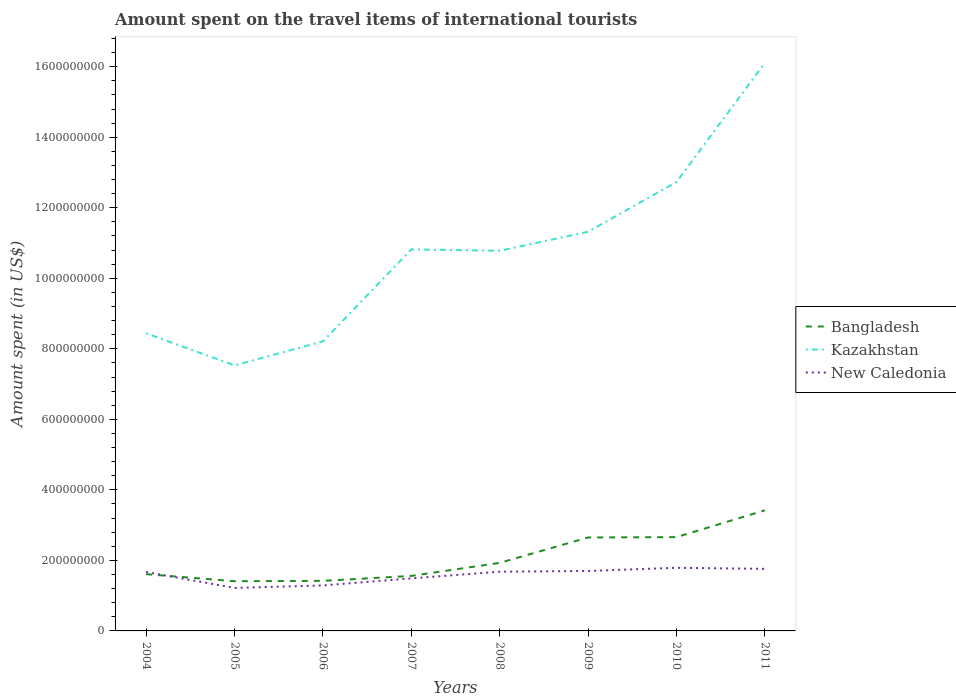How many different coloured lines are there?
Ensure brevity in your answer.  3. Across all years, what is the maximum amount spent on the travel items of international tourists in Kazakhstan?
Ensure brevity in your answer.  7.53e+08. In which year was the amount spent on the travel items of international tourists in Kazakhstan maximum?
Provide a short and direct response. 2005. What is the total amount spent on the travel items of international tourists in New Caledonia in the graph?
Ensure brevity in your answer.  -3.90e+07. What is the difference between the highest and the second highest amount spent on the travel items of international tourists in Bangladesh?
Provide a short and direct response. 2.01e+08. Is the amount spent on the travel items of international tourists in New Caledonia strictly greater than the amount spent on the travel items of international tourists in Bangladesh over the years?
Make the answer very short. No. How many years are there in the graph?
Ensure brevity in your answer.  8. Are the values on the major ticks of Y-axis written in scientific E-notation?
Provide a short and direct response. No. Does the graph contain any zero values?
Your answer should be very brief. No. Where does the legend appear in the graph?
Make the answer very short. Center right. How many legend labels are there?
Make the answer very short. 3. What is the title of the graph?
Offer a very short reply. Amount spent on the travel items of international tourists. Does "Palau" appear as one of the legend labels in the graph?
Provide a short and direct response. No. What is the label or title of the X-axis?
Offer a terse response. Years. What is the label or title of the Y-axis?
Provide a succinct answer. Amount spent (in US$). What is the Amount spent (in US$) of Bangladesh in 2004?
Provide a short and direct response. 1.61e+08. What is the Amount spent (in US$) of Kazakhstan in 2004?
Make the answer very short. 8.44e+08. What is the Amount spent (in US$) of New Caledonia in 2004?
Offer a very short reply. 1.67e+08. What is the Amount spent (in US$) in Bangladesh in 2005?
Your answer should be very brief. 1.41e+08. What is the Amount spent (in US$) of Kazakhstan in 2005?
Your answer should be compact. 7.53e+08. What is the Amount spent (in US$) of New Caledonia in 2005?
Your response must be concise. 1.22e+08. What is the Amount spent (in US$) of Bangladesh in 2006?
Offer a terse response. 1.42e+08. What is the Amount spent (in US$) in Kazakhstan in 2006?
Provide a succinct answer. 8.21e+08. What is the Amount spent (in US$) in New Caledonia in 2006?
Offer a terse response. 1.29e+08. What is the Amount spent (in US$) of Bangladesh in 2007?
Provide a succinct answer. 1.56e+08. What is the Amount spent (in US$) in Kazakhstan in 2007?
Offer a terse response. 1.08e+09. What is the Amount spent (in US$) in New Caledonia in 2007?
Make the answer very short. 1.49e+08. What is the Amount spent (in US$) of Bangladesh in 2008?
Your answer should be compact. 1.93e+08. What is the Amount spent (in US$) in Kazakhstan in 2008?
Your answer should be very brief. 1.08e+09. What is the Amount spent (in US$) in New Caledonia in 2008?
Make the answer very short. 1.68e+08. What is the Amount spent (in US$) of Bangladesh in 2009?
Your response must be concise. 2.65e+08. What is the Amount spent (in US$) in Kazakhstan in 2009?
Keep it short and to the point. 1.13e+09. What is the Amount spent (in US$) in New Caledonia in 2009?
Your answer should be compact. 1.70e+08. What is the Amount spent (in US$) in Bangladesh in 2010?
Provide a succinct answer. 2.66e+08. What is the Amount spent (in US$) in Kazakhstan in 2010?
Provide a succinct answer. 1.27e+09. What is the Amount spent (in US$) in New Caledonia in 2010?
Give a very brief answer. 1.79e+08. What is the Amount spent (in US$) in Bangladesh in 2011?
Your response must be concise. 3.42e+08. What is the Amount spent (in US$) of Kazakhstan in 2011?
Ensure brevity in your answer.  1.61e+09. What is the Amount spent (in US$) of New Caledonia in 2011?
Offer a very short reply. 1.76e+08. Across all years, what is the maximum Amount spent (in US$) of Bangladesh?
Your answer should be compact. 3.42e+08. Across all years, what is the maximum Amount spent (in US$) in Kazakhstan?
Offer a very short reply. 1.61e+09. Across all years, what is the maximum Amount spent (in US$) in New Caledonia?
Your answer should be compact. 1.79e+08. Across all years, what is the minimum Amount spent (in US$) of Bangladesh?
Your answer should be compact. 1.41e+08. Across all years, what is the minimum Amount spent (in US$) of Kazakhstan?
Give a very brief answer. 7.53e+08. Across all years, what is the minimum Amount spent (in US$) of New Caledonia?
Your answer should be compact. 1.22e+08. What is the total Amount spent (in US$) in Bangladesh in the graph?
Your answer should be very brief. 1.67e+09. What is the total Amount spent (in US$) in Kazakhstan in the graph?
Your response must be concise. 8.59e+09. What is the total Amount spent (in US$) of New Caledonia in the graph?
Offer a very short reply. 1.26e+09. What is the difference between the Amount spent (in US$) of Bangladesh in 2004 and that in 2005?
Ensure brevity in your answer.  2.00e+07. What is the difference between the Amount spent (in US$) in Kazakhstan in 2004 and that in 2005?
Give a very brief answer. 9.10e+07. What is the difference between the Amount spent (in US$) of New Caledonia in 2004 and that in 2005?
Your answer should be compact. 4.50e+07. What is the difference between the Amount spent (in US$) of Bangladesh in 2004 and that in 2006?
Offer a terse response. 1.90e+07. What is the difference between the Amount spent (in US$) in Kazakhstan in 2004 and that in 2006?
Make the answer very short. 2.30e+07. What is the difference between the Amount spent (in US$) of New Caledonia in 2004 and that in 2006?
Provide a short and direct response. 3.80e+07. What is the difference between the Amount spent (in US$) in Kazakhstan in 2004 and that in 2007?
Provide a succinct answer. -2.38e+08. What is the difference between the Amount spent (in US$) in New Caledonia in 2004 and that in 2007?
Provide a short and direct response. 1.80e+07. What is the difference between the Amount spent (in US$) in Bangladesh in 2004 and that in 2008?
Your answer should be compact. -3.20e+07. What is the difference between the Amount spent (in US$) of Kazakhstan in 2004 and that in 2008?
Make the answer very short. -2.34e+08. What is the difference between the Amount spent (in US$) of Bangladesh in 2004 and that in 2009?
Offer a very short reply. -1.04e+08. What is the difference between the Amount spent (in US$) of Kazakhstan in 2004 and that in 2009?
Your response must be concise. -2.88e+08. What is the difference between the Amount spent (in US$) in Bangladesh in 2004 and that in 2010?
Offer a terse response. -1.05e+08. What is the difference between the Amount spent (in US$) of Kazakhstan in 2004 and that in 2010?
Make the answer very short. -4.29e+08. What is the difference between the Amount spent (in US$) in New Caledonia in 2004 and that in 2010?
Ensure brevity in your answer.  -1.20e+07. What is the difference between the Amount spent (in US$) in Bangladesh in 2004 and that in 2011?
Keep it short and to the point. -1.81e+08. What is the difference between the Amount spent (in US$) in Kazakhstan in 2004 and that in 2011?
Offer a terse response. -7.67e+08. What is the difference between the Amount spent (in US$) of New Caledonia in 2004 and that in 2011?
Offer a terse response. -9.00e+06. What is the difference between the Amount spent (in US$) in Bangladesh in 2005 and that in 2006?
Keep it short and to the point. -1.00e+06. What is the difference between the Amount spent (in US$) in Kazakhstan in 2005 and that in 2006?
Your answer should be compact. -6.80e+07. What is the difference between the Amount spent (in US$) of New Caledonia in 2005 and that in 2006?
Your response must be concise. -7.00e+06. What is the difference between the Amount spent (in US$) in Bangladesh in 2005 and that in 2007?
Offer a terse response. -1.50e+07. What is the difference between the Amount spent (in US$) in Kazakhstan in 2005 and that in 2007?
Your answer should be compact. -3.29e+08. What is the difference between the Amount spent (in US$) of New Caledonia in 2005 and that in 2007?
Your response must be concise. -2.70e+07. What is the difference between the Amount spent (in US$) in Bangladesh in 2005 and that in 2008?
Keep it short and to the point. -5.20e+07. What is the difference between the Amount spent (in US$) of Kazakhstan in 2005 and that in 2008?
Provide a short and direct response. -3.25e+08. What is the difference between the Amount spent (in US$) of New Caledonia in 2005 and that in 2008?
Your response must be concise. -4.60e+07. What is the difference between the Amount spent (in US$) of Bangladesh in 2005 and that in 2009?
Offer a terse response. -1.24e+08. What is the difference between the Amount spent (in US$) of Kazakhstan in 2005 and that in 2009?
Offer a terse response. -3.79e+08. What is the difference between the Amount spent (in US$) of New Caledonia in 2005 and that in 2009?
Give a very brief answer. -4.80e+07. What is the difference between the Amount spent (in US$) of Bangladesh in 2005 and that in 2010?
Provide a short and direct response. -1.25e+08. What is the difference between the Amount spent (in US$) in Kazakhstan in 2005 and that in 2010?
Your answer should be very brief. -5.20e+08. What is the difference between the Amount spent (in US$) of New Caledonia in 2005 and that in 2010?
Make the answer very short. -5.70e+07. What is the difference between the Amount spent (in US$) of Bangladesh in 2005 and that in 2011?
Provide a short and direct response. -2.01e+08. What is the difference between the Amount spent (in US$) in Kazakhstan in 2005 and that in 2011?
Offer a very short reply. -8.58e+08. What is the difference between the Amount spent (in US$) in New Caledonia in 2005 and that in 2011?
Keep it short and to the point. -5.40e+07. What is the difference between the Amount spent (in US$) of Bangladesh in 2006 and that in 2007?
Offer a very short reply. -1.40e+07. What is the difference between the Amount spent (in US$) in Kazakhstan in 2006 and that in 2007?
Offer a terse response. -2.61e+08. What is the difference between the Amount spent (in US$) of New Caledonia in 2006 and that in 2007?
Your response must be concise. -2.00e+07. What is the difference between the Amount spent (in US$) of Bangladesh in 2006 and that in 2008?
Offer a very short reply. -5.10e+07. What is the difference between the Amount spent (in US$) of Kazakhstan in 2006 and that in 2008?
Your response must be concise. -2.57e+08. What is the difference between the Amount spent (in US$) in New Caledonia in 2006 and that in 2008?
Your answer should be compact. -3.90e+07. What is the difference between the Amount spent (in US$) in Bangladesh in 2006 and that in 2009?
Keep it short and to the point. -1.23e+08. What is the difference between the Amount spent (in US$) of Kazakhstan in 2006 and that in 2009?
Provide a succinct answer. -3.11e+08. What is the difference between the Amount spent (in US$) in New Caledonia in 2006 and that in 2009?
Your answer should be compact. -4.10e+07. What is the difference between the Amount spent (in US$) in Bangladesh in 2006 and that in 2010?
Provide a short and direct response. -1.24e+08. What is the difference between the Amount spent (in US$) in Kazakhstan in 2006 and that in 2010?
Keep it short and to the point. -4.52e+08. What is the difference between the Amount spent (in US$) in New Caledonia in 2006 and that in 2010?
Offer a terse response. -5.00e+07. What is the difference between the Amount spent (in US$) in Bangladesh in 2006 and that in 2011?
Make the answer very short. -2.00e+08. What is the difference between the Amount spent (in US$) of Kazakhstan in 2006 and that in 2011?
Offer a very short reply. -7.90e+08. What is the difference between the Amount spent (in US$) in New Caledonia in 2006 and that in 2011?
Make the answer very short. -4.70e+07. What is the difference between the Amount spent (in US$) in Bangladesh in 2007 and that in 2008?
Give a very brief answer. -3.70e+07. What is the difference between the Amount spent (in US$) in Kazakhstan in 2007 and that in 2008?
Make the answer very short. 4.00e+06. What is the difference between the Amount spent (in US$) of New Caledonia in 2007 and that in 2008?
Offer a very short reply. -1.90e+07. What is the difference between the Amount spent (in US$) of Bangladesh in 2007 and that in 2009?
Your answer should be very brief. -1.09e+08. What is the difference between the Amount spent (in US$) in Kazakhstan in 2007 and that in 2009?
Your answer should be compact. -5.00e+07. What is the difference between the Amount spent (in US$) of New Caledonia in 2007 and that in 2009?
Keep it short and to the point. -2.10e+07. What is the difference between the Amount spent (in US$) in Bangladesh in 2007 and that in 2010?
Give a very brief answer. -1.10e+08. What is the difference between the Amount spent (in US$) in Kazakhstan in 2007 and that in 2010?
Give a very brief answer. -1.91e+08. What is the difference between the Amount spent (in US$) of New Caledonia in 2007 and that in 2010?
Offer a very short reply. -3.00e+07. What is the difference between the Amount spent (in US$) in Bangladesh in 2007 and that in 2011?
Your answer should be very brief. -1.86e+08. What is the difference between the Amount spent (in US$) of Kazakhstan in 2007 and that in 2011?
Make the answer very short. -5.29e+08. What is the difference between the Amount spent (in US$) in New Caledonia in 2007 and that in 2011?
Provide a succinct answer. -2.70e+07. What is the difference between the Amount spent (in US$) of Bangladesh in 2008 and that in 2009?
Keep it short and to the point. -7.20e+07. What is the difference between the Amount spent (in US$) in Kazakhstan in 2008 and that in 2009?
Make the answer very short. -5.40e+07. What is the difference between the Amount spent (in US$) in New Caledonia in 2008 and that in 2009?
Offer a terse response. -2.00e+06. What is the difference between the Amount spent (in US$) in Bangladesh in 2008 and that in 2010?
Your answer should be very brief. -7.30e+07. What is the difference between the Amount spent (in US$) of Kazakhstan in 2008 and that in 2010?
Provide a short and direct response. -1.95e+08. What is the difference between the Amount spent (in US$) in New Caledonia in 2008 and that in 2010?
Ensure brevity in your answer.  -1.10e+07. What is the difference between the Amount spent (in US$) in Bangladesh in 2008 and that in 2011?
Provide a succinct answer. -1.49e+08. What is the difference between the Amount spent (in US$) in Kazakhstan in 2008 and that in 2011?
Keep it short and to the point. -5.33e+08. What is the difference between the Amount spent (in US$) of New Caledonia in 2008 and that in 2011?
Ensure brevity in your answer.  -8.00e+06. What is the difference between the Amount spent (in US$) of Kazakhstan in 2009 and that in 2010?
Give a very brief answer. -1.41e+08. What is the difference between the Amount spent (in US$) of New Caledonia in 2009 and that in 2010?
Your response must be concise. -9.00e+06. What is the difference between the Amount spent (in US$) in Bangladesh in 2009 and that in 2011?
Provide a succinct answer. -7.70e+07. What is the difference between the Amount spent (in US$) of Kazakhstan in 2009 and that in 2011?
Provide a short and direct response. -4.79e+08. What is the difference between the Amount spent (in US$) in New Caledonia in 2009 and that in 2011?
Your answer should be very brief. -6.00e+06. What is the difference between the Amount spent (in US$) of Bangladesh in 2010 and that in 2011?
Offer a very short reply. -7.60e+07. What is the difference between the Amount spent (in US$) in Kazakhstan in 2010 and that in 2011?
Your response must be concise. -3.38e+08. What is the difference between the Amount spent (in US$) of New Caledonia in 2010 and that in 2011?
Keep it short and to the point. 3.00e+06. What is the difference between the Amount spent (in US$) of Bangladesh in 2004 and the Amount spent (in US$) of Kazakhstan in 2005?
Provide a short and direct response. -5.92e+08. What is the difference between the Amount spent (in US$) in Bangladesh in 2004 and the Amount spent (in US$) in New Caledonia in 2005?
Keep it short and to the point. 3.90e+07. What is the difference between the Amount spent (in US$) of Kazakhstan in 2004 and the Amount spent (in US$) of New Caledonia in 2005?
Your answer should be very brief. 7.22e+08. What is the difference between the Amount spent (in US$) in Bangladesh in 2004 and the Amount spent (in US$) in Kazakhstan in 2006?
Provide a succinct answer. -6.60e+08. What is the difference between the Amount spent (in US$) of Bangladesh in 2004 and the Amount spent (in US$) of New Caledonia in 2006?
Your response must be concise. 3.20e+07. What is the difference between the Amount spent (in US$) in Kazakhstan in 2004 and the Amount spent (in US$) in New Caledonia in 2006?
Provide a short and direct response. 7.15e+08. What is the difference between the Amount spent (in US$) of Bangladesh in 2004 and the Amount spent (in US$) of Kazakhstan in 2007?
Ensure brevity in your answer.  -9.21e+08. What is the difference between the Amount spent (in US$) in Kazakhstan in 2004 and the Amount spent (in US$) in New Caledonia in 2007?
Keep it short and to the point. 6.95e+08. What is the difference between the Amount spent (in US$) of Bangladesh in 2004 and the Amount spent (in US$) of Kazakhstan in 2008?
Your answer should be very brief. -9.17e+08. What is the difference between the Amount spent (in US$) in Bangladesh in 2004 and the Amount spent (in US$) in New Caledonia in 2008?
Offer a terse response. -7.00e+06. What is the difference between the Amount spent (in US$) of Kazakhstan in 2004 and the Amount spent (in US$) of New Caledonia in 2008?
Your answer should be very brief. 6.76e+08. What is the difference between the Amount spent (in US$) in Bangladesh in 2004 and the Amount spent (in US$) in Kazakhstan in 2009?
Keep it short and to the point. -9.71e+08. What is the difference between the Amount spent (in US$) of Bangladesh in 2004 and the Amount spent (in US$) of New Caledonia in 2009?
Keep it short and to the point. -9.00e+06. What is the difference between the Amount spent (in US$) in Kazakhstan in 2004 and the Amount spent (in US$) in New Caledonia in 2009?
Provide a short and direct response. 6.74e+08. What is the difference between the Amount spent (in US$) of Bangladesh in 2004 and the Amount spent (in US$) of Kazakhstan in 2010?
Ensure brevity in your answer.  -1.11e+09. What is the difference between the Amount spent (in US$) in Bangladesh in 2004 and the Amount spent (in US$) in New Caledonia in 2010?
Your response must be concise. -1.80e+07. What is the difference between the Amount spent (in US$) of Kazakhstan in 2004 and the Amount spent (in US$) of New Caledonia in 2010?
Your answer should be compact. 6.65e+08. What is the difference between the Amount spent (in US$) of Bangladesh in 2004 and the Amount spent (in US$) of Kazakhstan in 2011?
Ensure brevity in your answer.  -1.45e+09. What is the difference between the Amount spent (in US$) of Bangladesh in 2004 and the Amount spent (in US$) of New Caledonia in 2011?
Offer a terse response. -1.50e+07. What is the difference between the Amount spent (in US$) of Kazakhstan in 2004 and the Amount spent (in US$) of New Caledonia in 2011?
Ensure brevity in your answer.  6.68e+08. What is the difference between the Amount spent (in US$) of Bangladesh in 2005 and the Amount spent (in US$) of Kazakhstan in 2006?
Keep it short and to the point. -6.80e+08. What is the difference between the Amount spent (in US$) in Bangladesh in 2005 and the Amount spent (in US$) in New Caledonia in 2006?
Your answer should be compact. 1.20e+07. What is the difference between the Amount spent (in US$) of Kazakhstan in 2005 and the Amount spent (in US$) of New Caledonia in 2006?
Your response must be concise. 6.24e+08. What is the difference between the Amount spent (in US$) in Bangladesh in 2005 and the Amount spent (in US$) in Kazakhstan in 2007?
Provide a succinct answer. -9.41e+08. What is the difference between the Amount spent (in US$) of Bangladesh in 2005 and the Amount spent (in US$) of New Caledonia in 2007?
Make the answer very short. -8.00e+06. What is the difference between the Amount spent (in US$) in Kazakhstan in 2005 and the Amount spent (in US$) in New Caledonia in 2007?
Offer a very short reply. 6.04e+08. What is the difference between the Amount spent (in US$) in Bangladesh in 2005 and the Amount spent (in US$) in Kazakhstan in 2008?
Make the answer very short. -9.37e+08. What is the difference between the Amount spent (in US$) in Bangladesh in 2005 and the Amount spent (in US$) in New Caledonia in 2008?
Offer a terse response. -2.70e+07. What is the difference between the Amount spent (in US$) in Kazakhstan in 2005 and the Amount spent (in US$) in New Caledonia in 2008?
Your response must be concise. 5.85e+08. What is the difference between the Amount spent (in US$) in Bangladesh in 2005 and the Amount spent (in US$) in Kazakhstan in 2009?
Provide a short and direct response. -9.91e+08. What is the difference between the Amount spent (in US$) in Bangladesh in 2005 and the Amount spent (in US$) in New Caledonia in 2009?
Provide a succinct answer. -2.90e+07. What is the difference between the Amount spent (in US$) in Kazakhstan in 2005 and the Amount spent (in US$) in New Caledonia in 2009?
Your answer should be very brief. 5.83e+08. What is the difference between the Amount spent (in US$) of Bangladesh in 2005 and the Amount spent (in US$) of Kazakhstan in 2010?
Keep it short and to the point. -1.13e+09. What is the difference between the Amount spent (in US$) in Bangladesh in 2005 and the Amount spent (in US$) in New Caledonia in 2010?
Keep it short and to the point. -3.80e+07. What is the difference between the Amount spent (in US$) in Kazakhstan in 2005 and the Amount spent (in US$) in New Caledonia in 2010?
Your answer should be very brief. 5.74e+08. What is the difference between the Amount spent (in US$) in Bangladesh in 2005 and the Amount spent (in US$) in Kazakhstan in 2011?
Your answer should be compact. -1.47e+09. What is the difference between the Amount spent (in US$) of Bangladesh in 2005 and the Amount spent (in US$) of New Caledonia in 2011?
Offer a terse response. -3.50e+07. What is the difference between the Amount spent (in US$) in Kazakhstan in 2005 and the Amount spent (in US$) in New Caledonia in 2011?
Provide a short and direct response. 5.77e+08. What is the difference between the Amount spent (in US$) in Bangladesh in 2006 and the Amount spent (in US$) in Kazakhstan in 2007?
Give a very brief answer. -9.40e+08. What is the difference between the Amount spent (in US$) in Bangladesh in 2006 and the Amount spent (in US$) in New Caledonia in 2007?
Make the answer very short. -7.00e+06. What is the difference between the Amount spent (in US$) of Kazakhstan in 2006 and the Amount spent (in US$) of New Caledonia in 2007?
Your answer should be very brief. 6.72e+08. What is the difference between the Amount spent (in US$) in Bangladesh in 2006 and the Amount spent (in US$) in Kazakhstan in 2008?
Offer a terse response. -9.36e+08. What is the difference between the Amount spent (in US$) of Bangladesh in 2006 and the Amount spent (in US$) of New Caledonia in 2008?
Provide a succinct answer. -2.60e+07. What is the difference between the Amount spent (in US$) in Kazakhstan in 2006 and the Amount spent (in US$) in New Caledonia in 2008?
Make the answer very short. 6.53e+08. What is the difference between the Amount spent (in US$) in Bangladesh in 2006 and the Amount spent (in US$) in Kazakhstan in 2009?
Your answer should be compact. -9.90e+08. What is the difference between the Amount spent (in US$) of Bangladesh in 2006 and the Amount spent (in US$) of New Caledonia in 2009?
Your answer should be very brief. -2.80e+07. What is the difference between the Amount spent (in US$) in Kazakhstan in 2006 and the Amount spent (in US$) in New Caledonia in 2009?
Your answer should be very brief. 6.51e+08. What is the difference between the Amount spent (in US$) in Bangladesh in 2006 and the Amount spent (in US$) in Kazakhstan in 2010?
Offer a very short reply. -1.13e+09. What is the difference between the Amount spent (in US$) of Bangladesh in 2006 and the Amount spent (in US$) of New Caledonia in 2010?
Your response must be concise. -3.70e+07. What is the difference between the Amount spent (in US$) in Kazakhstan in 2006 and the Amount spent (in US$) in New Caledonia in 2010?
Make the answer very short. 6.42e+08. What is the difference between the Amount spent (in US$) in Bangladesh in 2006 and the Amount spent (in US$) in Kazakhstan in 2011?
Keep it short and to the point. -1.47e+09. What is the difference between the Amount spent (in US$) of Bangladesh in 2006 and the Amount spent (in US$) of New Caledonia in 2011?
Ensure brevity in your answer.  -3.40e+07. What is the difference between the Amount spent (in US$) of Kazakhstan in 2006 and the Amount spent (in US$) of New Caledonia in 2011?
Make the answer very short. 6.45e+08. What is the difference between the Amount spent (in US$) in Bangladesh in 2007 and the Amount spent (in US$) in Kazakhstan in 2008?
Provide a succinct answer. -9.22e+08. What is the difference between the Amount spent (in US$) of Bangladesh in 2007 and the Amount spent (in US$) of New Caledonia in 2008?
Provide a short and direct response. -1.20e+07. What is the difference between the Amount spent (in US$) of Kazakhstan in 2007 and the Amount spent (in US$) of New Caledonia in 2008?
Offer a very short reply. 9.14e+08. What is the difference between the Amount spent (in US$) in Bangladesh in 2007 and the Amount spent (in US$) in Kazakhstan in 2009?
Make the answer very short. -9.76e+08. What is the difference between the Amount spent (in US$) of Bangladesh in 2007 and the Amount spent (in US$) of New Caledonia in 2009?
Your response must be concise. -1.40e+07. What is the difference between the Amount spent (in US$) in Kazakhstan in 2007 and the Amount spent (in US$) in New Caledonia in 2009?
Make the answer very short. 9.12e+08. What is the difference between the Amount spent (in US$) of Bangladesh in 2007 and the Amount spent (in US$) of Kazakhstan in 2010?
Your answer should be compact. -1.12e+09. What is the difference between the Amount spent (in US$) in Bangladesh in 2007 and the Amount spent (in US$) in New Caledonia in 2010?
Your answer should be compact. -2.30e+07. What is the difference between the Amount spent (in US$) in Kazakhstan in 2007 and the Amount spent (in US$) in New Caledonia in 2010?
Provide a short and direct response. 9.03e+08. What is the difference between the Amount spent (in US$) of Bangladesh in 2007 and the Amount spent (in US$) of Kazakhstan in 2011?
Provide a short and direct response. -1.46e+09. What is the difference between the Amount spent (in US$) in Bangladesh in 2007 and the Amount spent (in US$) in New Caledonia in 2011?
Keep it short and to the point. -2.00e+07. What is the difference between the Amount spent (in US$) in Kazakhstan in 2007 and the Amount spent (in US$) in New Caledonia in 2011?
Offer a very short reply. 9.06e+08. What is the difference between the Amount spent (in US$) of Bangladesh in 2008 and the Amount spent (in US$) of Kazakhstan in 2009?
Your answer should be very brief. -9.39e+08. What is the difference between the Amount spent (in US$) of Bangladesh in 2008 and the Amount spent (in US$) of New Caledonia in 2009?
Give a very brief answer. 2.30e+07. What is the difference between the Amount spent (in US$) in Kazakhstan in 2008 and the Amount spent (in US$) in New Caledonia in 2009?
Your answer should be compact. 9.08e+08. What is the difference between the Amount spent (in US$) in Bangladesh in 2008 and the Amount spent (in US$) in Kazakhstan in 2010?
Give a very brief answer. -1.08e+09. What is the difference between the Amount spent (in US$) of Bangladesh in 2008 and the Amount spent (in US$) of New Caledonia in 2010?
Keep it short and to the point. 1.40e+07. What is the difference between the Amount spent (in US$) of Kazakhstan in 2008 and the Amount spent (in US$) of New Caledonia in 2010?
Give a very brief answer. 8.99e+08. What is the difference between the Amount spent (in US$) of Bangladesh in 2008 and the Amount spent (in US$) of Kazakhstan in 2011?
Keep it short and to the point. -1.42e+09. What is the difference between the Amount spent (in US$) in Bangladesh in 2008 and the Amount spent (in US$) in New Caledonia in 2011?
Give a very brief answer. 1.70e+07. What is the difference between the Amount spent (in US$) of Kazakhstan in 2008 and the Amount spent (in US$) of New Caledonia in 2011?
Your response must be concise. 9.02e+08. What is the difference between the Amount spent (in US$) in Bangladesh in 2009 and the Amount spent (in US$) in Kazakhstan in 2010?
Your response must be concise. -1.01e+09. What is the difference between the Amount spent (in US$) in Bangladesh in 2009 and the Amount spent (in US$) in New Caledonia in 2010?
Give a very brief answer. 8.60e+07. What is the difference between the Amount spent (in US$) of Kazakhstan in 2009 and the Amount spent (in US$) of New Caledonia in 2010?
Provide a succinct answer. 9.53e+08. What is the difference between the Amount spent (in US$) in Bangladesh in 2009 and the Amount spent (in US$) in Kazakhstan in 2011?
Make the answer very short. -1.35e+09. What is the difference between the Amount spent (in US$) of Bangladesh in 2009 and the Amount spent (in US$) of New Caledonia in 2011?
Give a very brief answer. 8.90e+07. What is the difference between the Amount spent (in US$) in Kazakhstan in 2009 and the Amount spent (in US$) in New Caledonia in 2011?
Give a very brief answer. 9.56e+08. What is the difference between the Amount spent (in US$) in Bangladesh in 2010 and the Amount spent (in US$) in Kazakhstan in 2011?
Offer a terse response. -1.34e+09. What is the difference between the Amount spent (in US$) in Bangladesh in 2010 and the Amount spent (in US$) in New Caledonia in 2011?
Offer a very short reply. 9.00e+07. What is the difference between the Amount spent (in US$) in Kazakhstan in 2010 and the Amount spent (in US$) in New Caledonia in 2011?
Provide a succinct answer. 1.10e+09. What is the average Amount spent (in US$) in Bangladesh per year?
Offer a very short reply. 2.08e+08. What is the average Amount spent (in US$) in Kazakhstan per year?
Offer a very short reply. 1.07e+09. What is the average Amount spent (in US$) of New Caledonia per year?
Make the answer very short. 1.58e+08. In the year 2004, what is the difference between the Amount spent (in US$) of Bangladesh and Amount spent (in US$) of Kazakhstan?
Your answer should be very brief. -6.83e+08. In the year 2004, what is the difference between the Amount spent (in US$) in Bangladesh and Amount spent (in US$) in New Caledonia?
Your answer should be compact. -6.00e+06. In the year 2004, what is the difference between the Amount spent (in US$) in Kazakhstan and Amount spent (in US$) in New Caledonia?
Ensure brevity in your answer.  6.77e+08. In the year 2005, what is the difference between the Amount spent (in US$) of Bangladesh and Amount spent (in US$) of Kazakhstan?
Your answer should be very brief. -6.12e+08. In the year 2005, what is the difference between the Amount spent (in US$) of Bangladesh and Amount spent (in US$) of New Caledonia?
Offer a very short reply. 1.90e+07. In the year 2005, what is the difference between the Amount spent (in US$) in Kazakhstan and Amount spent (in US$) in New Caledonia?
Offer a terse response. 6.31e+08. In the year 2006, what is the difference between the Amount spent (in US$) of Bangladesh and Amount spent (in US$) of Kazakhstan?
Your response must be concise. -6.79e+08. In the year 2006, what is the difference between the Amount spent (in US$) in Bangladesh and Amount spent (in US$) in New Caledonia?
Keep it short and to the point. 1.30e+07. In the year 2006, what is the difference between the Amount spent (in US$) in Kazakhstan and Amount spent (in US$) in New Caledonia?
Provide a short and direct response. 6.92e+08. In the year 2007, what is the difference between the Amount spent (in US$) of Bangladesh and Amount spent (in US$) of Kazakhstan?
Provide a succinct answer. -9.26e+08. In the year 2007, what is the difference between the Amount spent (in US$) in Kazakhstan and Amount spent (in US$) in New Caledonia?
Ensure brevity in your answer.  9.33e+08. In the year 2008, what is the difference between the Amount spent (in US$) in Bangladesh and Amount spent (in US$) in Kazakhstan?
Provide a succinct answer. -8.85e+08. In the year 2008, what is the difference between the Amount spent (in US$) of Bangladesh and Amount spent (in US$) of New Caledonia?
Give a very brief answer. 2.50e+07. In the year 2008, what is the difference between the Amount spent (in US$) of Kazakhstan and Amount spent (in US$) of New Caledonia?
Your response must be concise. 9.10e+08. In the year 2009, what is the difference between the Amount spent (in US$) of Bangladesh and Amount spent (in US$) of Kazakhstan?
Your answer should be compact. -8.67e+08. In the year 2009, what is the difference between the Amount spent (in US$) in Bangladesh and Amount spent (in US$) in New Caledonia?
Your response must be concise. 9.50e+07. In the year 2009, what is the difference between the Amount spent (in US$) of Kazakhstan and Amount spent (in US$) of New Caledonia?
Give a very brief answer. 9.62e+08. In the year 2010, what is the difference between the Amount spent (in US$) of Bangladesh and Amount spent (in US$) of Kazakhstan?
Offer a terse response. -1.01e+09. In the year 2010, what is the difference between the Amount spent (in US$) in Bangladesh and Amount spent (in US$) in New Caledonia?
Your response must be concise. 8.70e+07. In the year 2010, what is the difference between the Amount spent (in US$) in Kazakhstan and Amount spent (in US$) in New Caledonia?
Offer a terse response. 1.09e+09. In the year 2011, what is the difference between the Amount spent (in US$) in Bangladesh and Amount spent (in US$) in Kazakhstan?
Offer a terse response. -1.27e+09. In the year 2011, what is the difference between the Amount spent (in US$) in Bangladesh and Amount spent (in US$) in New Caledonia?
Keep it short and to the point. 1.66e+08. In the year 2011, what is the difference between the Amount spent (in US$) of Kazakhstan and Amount spent (in US$) of New Caledonia?
Ensure brevity in your answer.  1.44e+09. What is the ratio of the Amount spent (in US$) of Bangladesh in 2004 to that in 2005?
Your answer should be very brief. 1.14. What is the ratio of the Amount spent (in US$) in Kazakhstan in 2004 to that in 2005?
Offer a very short reply. 1.12. What is the ratio of the Amount spent (in US$) in New Caledonia in 2004 to that in 2005?
Offer a terse response. 1.37. What is the ratio of the Amount spent (in US$) in Bangladesh in 2004 to that in 2006?
Your answer should be very brief. 1.13. What is the ratio of the Amount spent (in US$) in Kazakhstan in 2004 to that in 2006?
Keep it short and to the point. 1.03. What is the ratio of the Amount spent (in US$) of New Caledonia in 2004 to that in 2006?
Offer a terse response. 1.29. What is the ratio of the Amount spent (in US$) of Bangladesh in 2004 to that in 2007?
Ensure brevity in your answer.  1.03. What is the ratio of the Amount spent (in US$) of Kazakhstan in 2004 to that in 2007?
Offer a terse response. 0.78. What is the ratio of the Amount spent (in US$) of New Caledonia in 2004 to that in 2007?
Your answer should be compact. 1.12. What is the ratio of the Amount spent (in US$) in Bangladesh in 2004 to that in 2008?
Keep it short and to the point. 0.83. What is the ratio of the Amount spent (in US$) of Kazakhstan in 2004 to that in 2008?
Offer a very short reply. 0.78. What is the ratio of the Amount spent (in US$) in Bangladesh in 2004 to that in 2009?
Provide a succinct answer. 0.61. What is the ratio of the Amount spent (in US$) in Kazakhstan in 2004 to that in 2009?
Your answer should be compact. 0.75. What is the ratio of the Amount spent (in US$) in New Caledonia in 2004 to that in 2009?
Give a very brief answer. 0.98. What is the ratio of the Amount spent (in US$) in Bangladesh in 2004 to that in 2010?
Provide a short and direct response. 0.61. What is the ratio of the Amount spent (in US$) in Kazakhstan in 2004 to that in 2010?
Offer a terse response. 0.66. What is the ratio of the Amount spent (in US$) of New Caledonia in 2004 to that in 2010?
Give a very brief answer. 0.93. What is the ratio of the Amount spent (in US$) in Bangladesh in 2004 to that in 2011?
Provide a succinct answer. 0.47. What is the ratio of the Amount spent (in US$) in Kazakhstan in 2004 to that in 2011?
Provide a short and direct response. 0.52. What is the ratio of the Amount spent (in US$) in New Caledonia in 2004 to that in 2011?
Provide a succinct answer. 0.95. What is the ratio of the Amount spent (in US$) in Kazakhstan in 2005 to that in 2006?
Make the answer very short. 0.92. What is the ratio of the Amount spent (in US$) in New Caledonia in 2005 to that in 2006?
Offer a very short reply. 0.95. What is the ratio of the Amount spent (in US$) of Bangladesh in 2005 to that in 2007?
Your answer should be very brief. 0.9. What is the ratio of the Amount spent (in US$) in Kazakhstan in 2005 to that in 2007?
Give a very brief answer. 0.7. What is the ratio of the Amount spent (in US$) in New Caledonia in 2005 to that in 2007?
Make the answer very short. 0.82. What is the ratio of the Amount spent (in US$) in Bangladesh in 2005 to that in 2008?
Make the answer very short. 0.73. What is the ratio of the Amount spent (in US$) in Kazakhstan in 2005 to that in 2008?
Keep it short and to the point. 0.7. What is the ratio of the Amount spent (in US$) in New Caledonia in 2005 to that in 2008?
Provide a short and direct response. 0.73. What is the ratio of the Amount spent (in US$) of Bangladesh in 2005 to that in 2009?
Ensure brevity in your answer.  0.53. What is the ratio of the Amount spent (in US$) of Kazakhstan in 2005 to that in 2009?
Ensure brevity in your answer.  0.67. What is the ratio of the Amount spent (in US$) of New Caledonia in 2005 to that in 2009?
Your answer should be compact. 0.72. What is the ratio of the Amount spent (in US$) in Bangladesh in 2005 to that in 2010?
Ensure brevity in your answer.  0.53. What is the ratio of the Amount spent (in US$) of Kazakhstan in 2005 to that in 2010?
Your answer should be very brief. 0.59. What is the ratio of the Amount spent (in US$) of New Caledonia in 2005 to that in 2010?
Provide a succinct answer. 0.68. What is the ratio of the Amount spent (in US$) in Bangladesh in 2005 to that in 2011?
Your answer should be compact. 0.41. What is the ratio of the Amount spent (in US$) in Kazakhstan in 2005 to that in 2011?
Ensure brevity in your answer.  0.47. What is the ratio of the Amount spent (in US$) in New Caledonia in 2005 to that in 2011?
Provide a short and direct response. 0.69. What is the ratio of the Amount spent (in US$) of Bangladesh in 2006 to that in 2007?
Provide a short and direct response. 0.91. What is the ratio of the Amount spent (in US$) of Kazakhstan in 2006 to that in 2007?
Keep it short and to the point. 0.76. What is the ratio of the Amount spent (in US$) of New Caledonia in 2006 to that in 2007?
Make the answer very short. 0.87. What is the ratio of the Amount spent (in US$) in Bangladesh in 2006 to that in 2008?
Offer a very short reply. 0.74. What is the ratio of the Amount spent (in US$) of Kazakhstan in 2006 to that in 2008?
Your response must be concise. 0.76. What is the ratio of the Amount spent (in US$) in New Caledonia in 2006 to that in 2008?
Your answer should be compact. 0.77. What is the ratio of the Amount spent (in US$) in Bangladesh in 2006 to that in 2009?
Offer a terse response. 0.54. What is the ratio of the Amount spent (in US$) of Kazakhstan in 2006 to that in 2009?
Your answer should be very brief. 0.73. What is the ratio of the Amount spent (in US$) of New Caledonia in 2006 to that in 2009?
Make the answer very short. 0.76. What is the ratio of the Amount spent (in US$) of Bangladesh in 2006 to that in 2010?
Offer a very short reply. 0.53. What is the ratio of the Amount spent (in US$) in Kazakhstan in 2006 to that in 2010?
Provide a succinct answer. 0.64. What is the ratio of the Amount spent (in US$) in New Caledonia in 2006 to that in 2010?
Provide a succinct answer. 0.72. What is the ratio of the Amount spent (in US$) of Bangladesh in 2006 to that in 2011?
Give a very brief answer. 0.42. What is the ratio of the Amount spent (in US$) in Kazakhstan in 2006 to that in 2011?
Provide a succinct answer. 0.51. What is the ratio of the Amount spent (in US$) of New Caledonia in 2006 to that in 2011?
Ensure brevity in your answer.  0.73. What is the ratio of the Amount spent (in US$) in Bangladesh in 2007 to that in 2008?
Your answer should be compact. 0.81. What is the ratio of the Amount spent (in US$) of Kazakhstan in 2007 to that in 2008?
Give a very brief answer. 1. What is the ratio of the Amount spent (in US$) of New Caledonia in 2007 to that in 2008?
Your answer should be compact. 0.89. What is the ratio of the Amount spent (in US$) in Bangladesh in 2007 to that in 2009?
Ensure brevity in your answer.  0.59. What is the ratio of the Amount spent (in US$) in Kazakhstan in 2007 to that in 2009?
Offer a very short reply. 0.96. What is the ratio of the Amount spent (in US$) in New Caledonia in 2007 to that in 2009?
Your answer should be very brief. 0.88. What is the ratio of the Amount spent (in US$) in Bangladesh in 2007 to that in 2010?
Make the answer very short. 0.59. What is the ratio of the Amount spent (in US$) of Kazakhstan in 2007 to that in 2010?
Your answer should be compact. 0.85. What is the ratio of the Amount spent (in US$) in New Caledonia in 2007 to that in 2010?
Your response must be concise. 0.83. What is the ratio of the Amount spent (in US$) in Bangladesh in 2007 to that in 2011?
Offer a terse response. 0.46. What is the ratio of the Amount spent (in US$) of Kazakhstan in 2007 to that in 2011?
Offer a terse response. 0.67. What is the ratio of the Amount spent (in US$) of New Caledonia in 2007 to that in 2011?
Your response must be concise. 0.85. What is the ratio of the Amount spent (in US$) of Bangladesh in 2008 to that in 2009?
Make the answer very short. 0.73. What is the ratio of the Amount spent (in US$) in Kazakhstan in 2008 to that in 2009?
Provide a succinct answer. 0.95. What is the ratio of the Amount spent (in US$) of New Caledonia in 2008 to that in 2009?
Offer a terse response. 0.99. What is the ratio of the Amount spent (in US$) of Bangladesh in 2008 to that in 2010?
Make the answer very short. 0.73. What is the ratio of the Amount spent (in US$) in Kazakhstan in 2008 to that in 2010?
Keep it short and to the point. 0.85. What is the ratio of the Amount spent (in US$) of New Caledonia in 2008 to that in 2010?
Keep it short and to the point. 0.94. What is the ratio of the Amount spent (in US$) of Bangladesh in 2008 to that in 2011?
Offer a terse response. 0.56. What is the ratio of the Amount spent (in US$) of Kazakhstan in 2008 to that in 2011?
Your response must be concise. 0.67. What is the ratio of the Amount spent (in US$) of New Caledonia in 2008 to that in 2011?
Your response must be concise. 0.95. What is the ratio of the Amount spent (in US$) of Bangladesh in 2009 to that in 2010?
Provide a short and direct response. 1. What is the ratio of the Amount spent (in US$) in Kazakhstan in 2009 to that in 2010?
Offer a very short reply. 0.89. What is the ratio of the Amount spent (in US$) in New Caledonia in 2009 to that in 2010?
Your answer should be very brief. 0.95. What is the ratio of the Amount spent (in US$) in Bangladesh in 2009 to that in 2011?
Keep it short and to the point. 0.77. What is the ratio of the Amount spent (in US$) in Kazakhstan in 2009 to that in 2011?
Your answer should be compact. 0.7. What is the ratio of the Amount spent (in US$) of New Caledonia in 2009 to that in 2011?
Your answer should be very brief. 0.97. What is the ratio of the Amount spent (in US$) in Kazakhstan in 2010 to that in 2011?
Your response must be concise. 0.79. What is the difference between the highest and the second highest Amount spent (in US$) in Bangladesh?
Your answer should be very brief. 7.60e+07. What is the difference between the highest and the second highest Amount spent (in US$) in Kazakhstan?
Your response must be concise. 3.38e+08. What is the difference between the highest and the second highest Amount spent (in US$) in New Caledonia?
Offer a terse response. 3.00e+06. What is the difference between the highest and the lowest Amount spent (in US$) of Bangladesh?
Provide a short and direct response. 2.01e+08. What is the difference between the highest and the lowest Amount spent (in US$) of Kazakhstan?
Provide a short and direct response. 8.58e+08. What is the difference between the highest and the lowest Amount spent (in US$) of New Caledonia?
Give a very brief answer. 5.70e+07. 